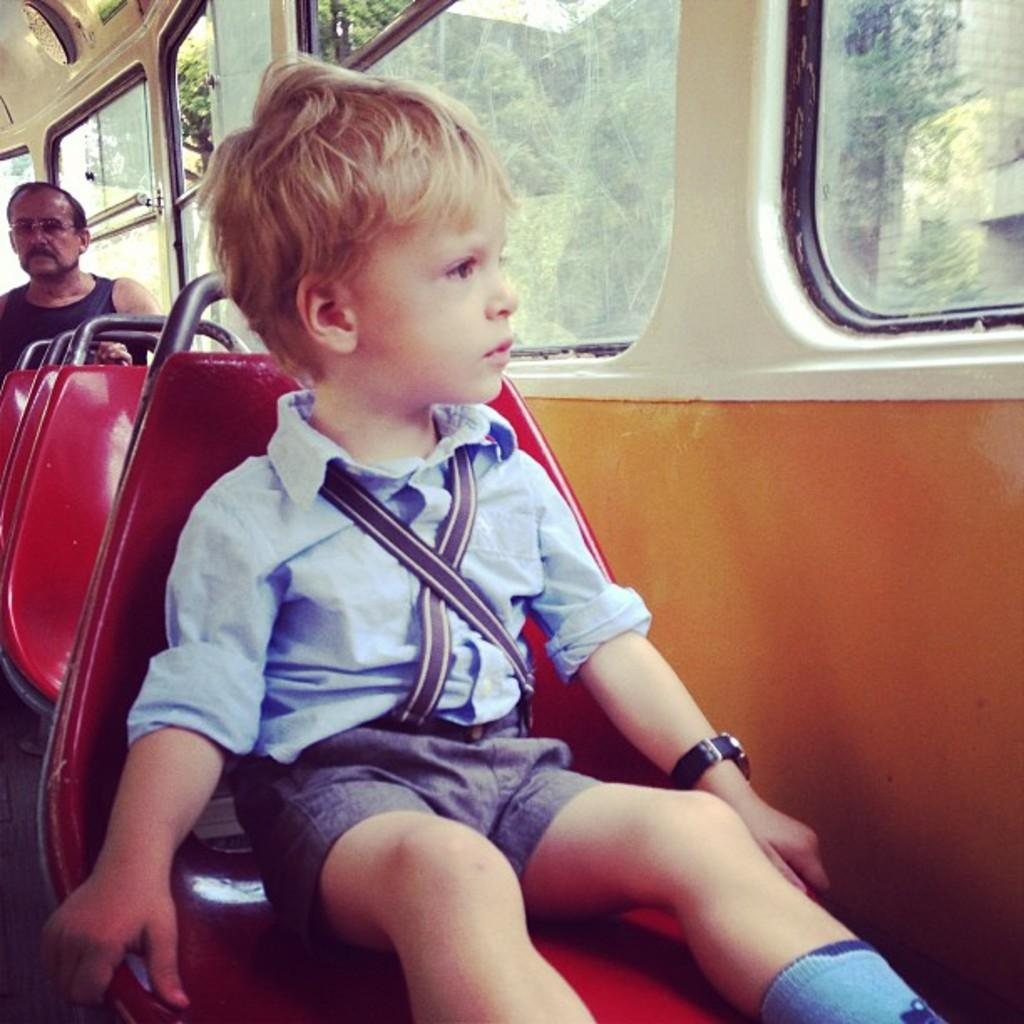How many people are sitting in the bus in the image? There are two people sitting in the bus in the image. What feature does the bus have that allows passengers to see outside? The bus has windows. What can be seen outside the bus windows? Trees and buildings are visible outside the bus windows. What type of lumber is being transported on the bus in the image? There is no lumber visible in the image; it features two people sitting in a bus with windows. How is the waste being managed on the bus in the image? There is no mention of waste management in the image; it only shows two people sitting in a bus with windows. 